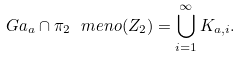<formula> <loc_0><loc_0><loc_500><loc_500>\ G a _ { a } \cap \pi _ { 2 } \ m e n o ( Z _ { 2 } ) = \bigcup _ { i = 1 } ^ { \infty } K _ { a , i } .</formula> 